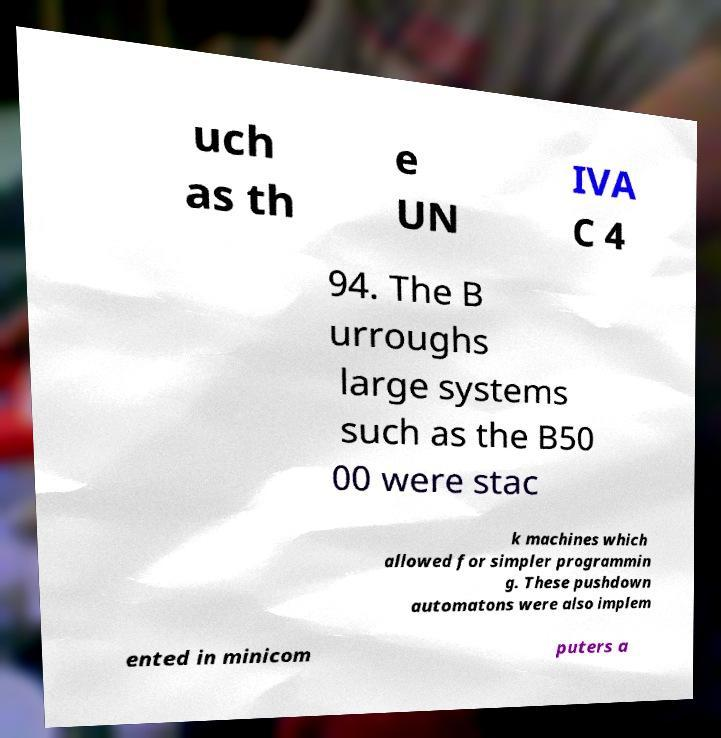I need the written content from this picture converted into text. Can you do that? uch as th e UN IVA C 4 94. The B urroughs large systems such as the B50 00 were stac k machines which allowed for simpler programmin g. These pushdown automatons were also implem ented in minicom puters a 